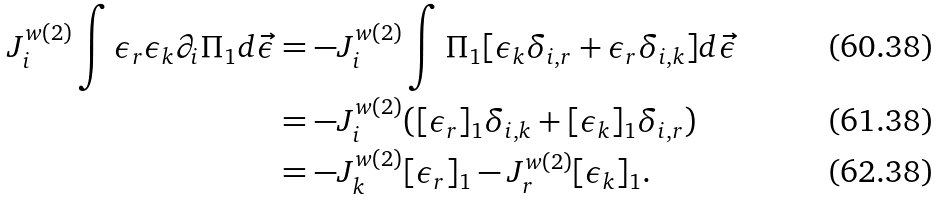Convert formula to latex. <formula><loc_0><loc_0><loc_500><loc_500>J _ { i } ^ { w ( 2 ) } \int \epsilon _ { r } \epsilon _ { k } \partial _ { i } \Pi _ { 1 } d { \vec { \epsilon } } & = - J _ { i } ^ { w ( 2 ) } \int \Pi _ { 1 } [ \epsilon _ { k } \delta _ { i , r } + \epsilon _ { r } \delta _ { i , k } ] d { \vec { \epsilon } } \\ & = - J _ { i } ^ { w ( 2 ) } ( [ \epsilon _ { r } ] _ { 1 } \delta _ { i , k } + [ \epsilon _ { k } ] _ { 1 } \delta _ { i , r } ) \\ & = - J _ { k } ^ { w ( 2 ) } [ \epsilon _ { r } ] _ { 1 } - J _ { r } ^ { w ( 2 ) } [ \epsilon _ { k } ] _ { 1 } .</formula> 